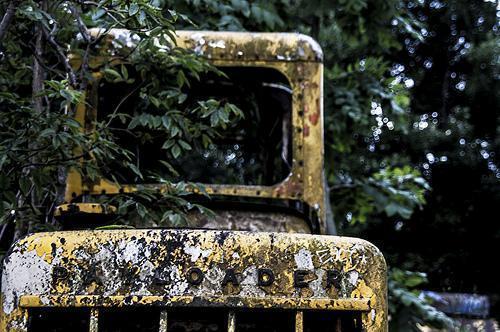How many black letters are there?
Give a very brief answer. 9. 